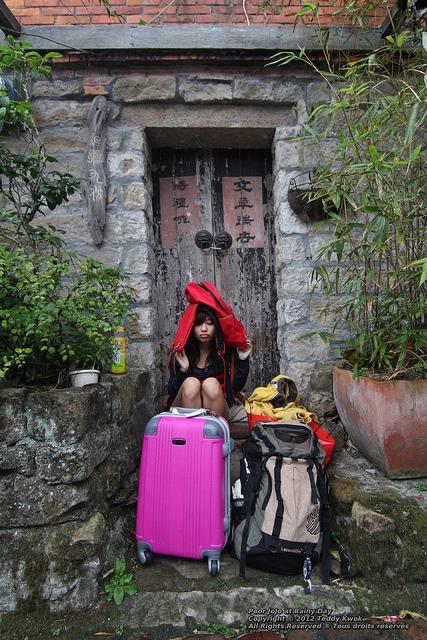Where is the girl sitting?
Quick response, please. Steps. What country is this?
Give a very brief answer. China. What's the girl doing?
Concise answer only. Sitting. 